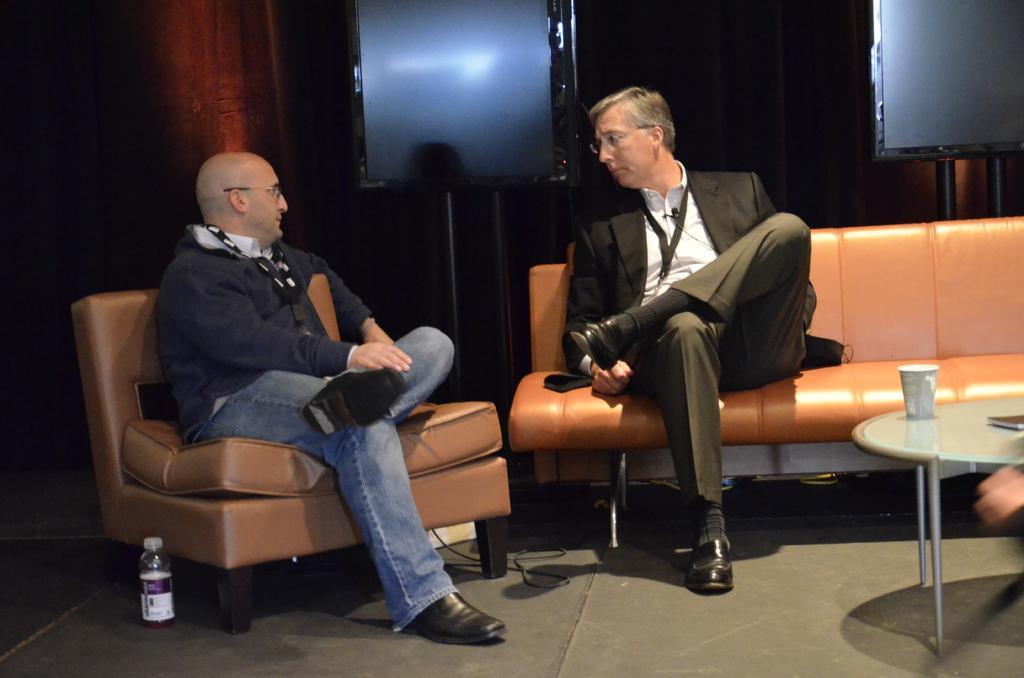In one or two sentences, can you explain what this image depicts? In this image in the center there are two persons who are sitting on a couch and talking and there is one table. On the table there is one cup, on the left side there is one bottle on the floor and in the background there is a wall and some boards. 